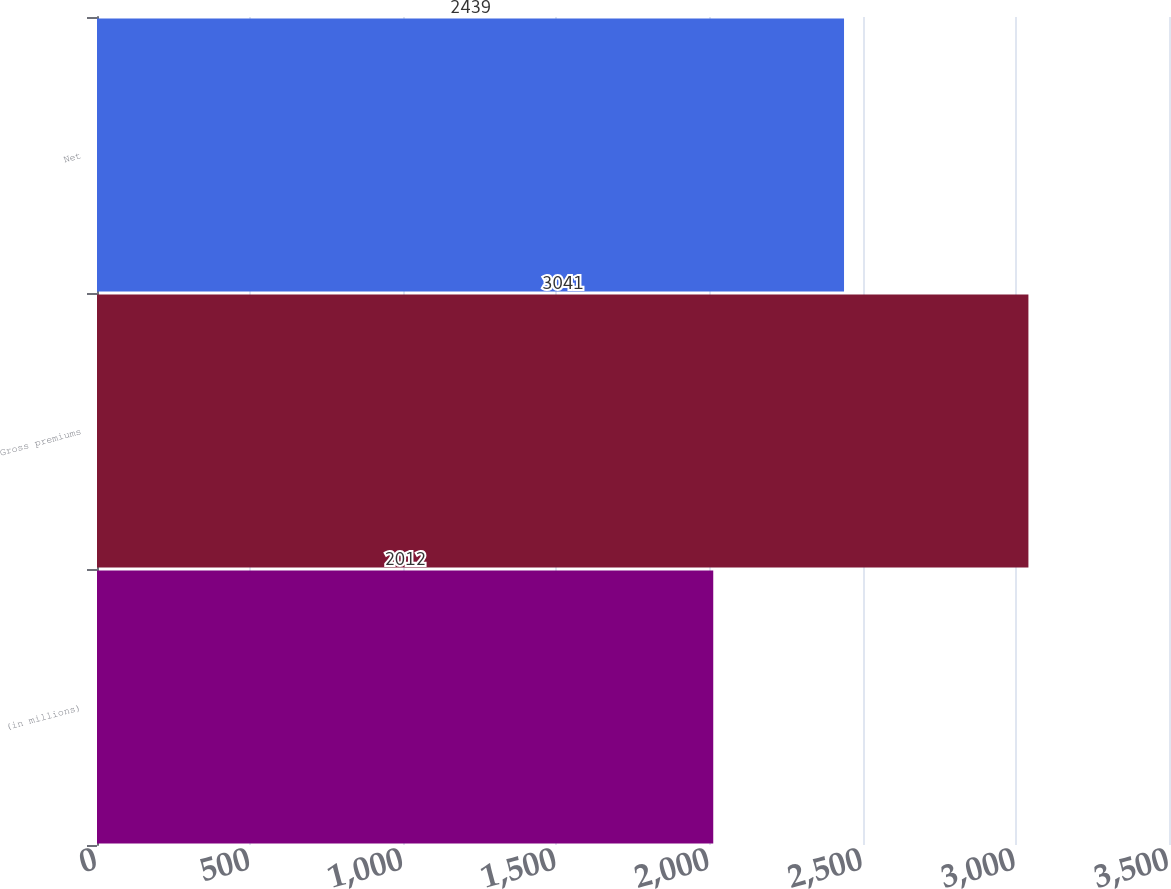Convert chart to OTSL. <chart><loc_0><loc_0><loc_500><loc_500><bar_chart><fcel>(in millions)<fcel>Gross premiums<fcel>Net<nl><fcel>2012<fcel>3041<fcel>2439<nl></chart> 